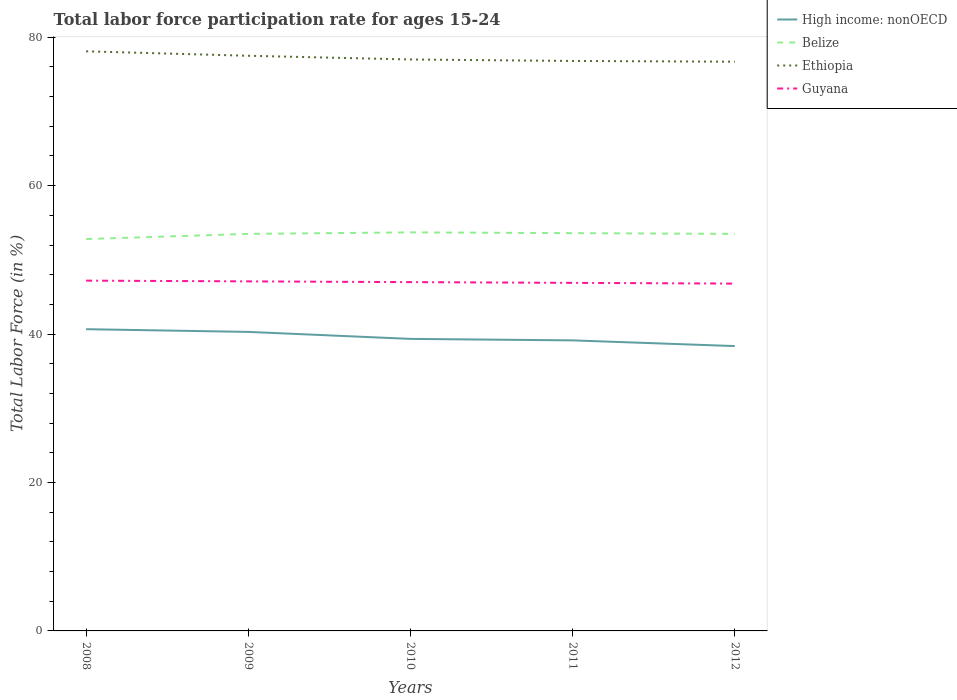Does the line corresponding to Belize intersect with the line corresponding to Ethiopia?
Your response must be concise. No. Is the number of lines equal to the number of legend labels?
Make the answer very short. Yes. Across all years, what is the maximum labor force participation rate in Belize?
Provide a short and direct response. 52.8. What is the total labor force participation rate in Ethiopia in the graph?
Your answer should be compact. 0.6. What is the difference between the highest and the second highest labor force participation rate in Ethiopia?
Ensure brevity in your answer.  1.4. What is the difference between the highest and the lowest labor force participation rate in Ethiopia?
Your response must be concise. 2. Is the labor force participation rate in Guyana strictly greater than the labor force participation rate in High income: nonOECD over the years?
Your answer should be compact. No. How many lines are there?
Your response must be concise. 4. What is the difference between two consecutive major ticks on the Y-axis?
Give a very brief answer. 20. Are the values on the major ticks of Y-axis written in scientific E-notation?
Offer a terse response. No. Does the graph contain grids?
Ensure brevity in your answer.  No. How many legend labels are there?
Keep it short and to the point. 4. What is the title of the graph?
Provide a short and direct response. Total labor force participation rate for ages 15-24. Does "Dominican Republic" appear as one of the legend labels in the graph?
Ensure brevity in your answer.  No. What is the Total Labor Force (in %) in High income: nonOECD in 2008?
Keep it short and to the point. 40.66. What is the Total Labor Force (in %) in Belize in 2008?
Your response must be concise. 52.8. What is the Total Labor Force (in %) in Ethiopia in 2008?
Your answer should be compact. 78.1. What is the Total Labor Force (in %) in Guyana in 2008?
Make the answer very short. 47.2. What is the Total Labor Force (in %) in High income: nonOECD in 2009?
Keep it short and to the point. 40.29. What is the Total Labor Force (in %) of Belize in 2009?
Give a very brief answer. 53.5. What is the Total Labor Force (in %) of Ethiopia in 2009?
Your answer should be very brief. 77.5. What is the Total Labor Force (in %) in Guyana in 2009?
Ensure brevity in your answer.  47.1. What is the Total Labor Force (in %) of High income: nonOECD in 2010?
Your answer should be compact. 39.35. What is the Total Labor Force (in %) in Belize in 2010?
Your answer should be compact. 53.7. What is the Total Labor Force (in %) in Ethiopia in 2010?
Keep it short and to the point. 77. What is the Total Labor Force (in %) of Guyana in 2010?
Keep it short and to the point. 47. What is the Total Labor Force (in %) in High income: nonOECD in 2011?
Your answer should be very brief. 39.15. What is the Total Labor Force (in %) of Belize in 2011?
Ensure brevity in your answer.  53.6. What is the Total Labor Force (in %) of Ethiopia in 2011?
Offer a very short reply. 76.8. What is the Total Labor Force (in %) of Guyana in 2011?
Your answer should be compact. 46.9. What is the Total Labor Force (in %) in High income: nonOECD in 2012?
Keep it short and to the point. 38.38. What is the Total Labor Force (in %) in Belize in 2012?
Your answer should be very brief. 53.5. What is the Total Labor Force (in %) of Ethiopia in 2012?
Provide a succinct answer. 76.7. What is the Total Labor Force (in %) of Guyana in 2012?
Provide a short and direct response. 46.8. Across all years, what is the maximum Total Labor Force (in %) of High income: nonOECD?
Offer a very short reply. 40.66. Across all years, what is the maximum Total Labor Force (in %) of Belize?
Offer a very short reply. 53.7. Across all years, what is the maximum Total Labor Force (in %) in Ethiopia?
Provide a succinct answer. 78.1. Across all years, what is the maximum Total Labor Force (in %) of Guyana?
Your answer should be very brief. 47.2. Across all years, what is the minimum Total Labor Force (in %) in High income: nonOECD?
Your answer should be compact. 38.38. Across all years, what is the minimum Total Labor Force (in %) in Belize?
Your answer should be compact. 52.8. Across all years, what is the minimum Total Labor Force (in %) of Ethiopia?
Give a very brief answer. 76.7. Across all years, what is the minimum Total Labor Force (in %) in Guyana?
Keep it short and to the point. 46.8. What is the total Total Labor Force (in %) of High income: nonOECD in the graph?
Offer a very short reply. 197.83. What is the total Total Labor Force (in %) of Belize in the graph?
Keep it short and to the point. 267.1. What is the total Total Labor Force (in %) in Ethiopia in the graph?
Give a very brief answer. 386.1. What is the total Total Labor Force (in %) in Guyana in the graph?
Your response must be concise. 235. What is the difference between the Total Labor Force (in %) of High income: nonOECD in 2008 and that in 2009?
Make the answer very short. 0.37. What is the difference between the Total Labor Force (in %) in Belize in 2008 and that in 2009?
Make the answer very short. -0.7. What is the difference between the Total Labor Force (in %) in High income: nonOECD in 2008 and that in 2010?
Provide a short and direct response. 1.31. What is the difference between the Total Labor Force (in %) of Belize in 2008 and that in 2010?
Make the answer very short. -0.9. What is the difference between the Total Labor Force (in %) of High income: nonOECD in 2008 and that in 2011?
Your answer should be very brief. 1.51. What is the difference between the Total Labor Force (in %) of Belize in 2008 and that in 2011?
Provide a succinct answer. -0.8. What is the difference between the Total Labor Force (in %) of High income: nonOECD in 2008 and that in 2012?
Provide a short and direct response. 2.28. What is the difference between the Total Labor Force (in %) of Belize in 2008 and that in 2012?
Make the answer very short. -0.7. What is the difference between the Total Labor Force (in %) in Guyana in 2008 and that in 2012?
Offer a terse response. 0.4. What is the difference between the Total Labor Force (in %) of High income: nonOECD in 2009 and that in 2010?
Provide a succinct answer. 0.94. What is the difference between the Total Labor Force (in %) of Belize in 2009 and that in 2010?
Keep it short and to the point. -0.2. What is the difference between the Total Labor Force (in %) of Ethiopia in 2009 and that in 2010?
Offer a terse response. 0.5. What is the difference between the Total Labor Force (in %) of Guyana in 2009 and that in 2010?
Your response must be concise. 0.1. What is the difference between the Total Labor Force (in %) of High income: nonOECD in 2009 and that in 2011?
Your response must be concise. 1.14. What is the difference between the Total Labor Force (in %) in Belize in 2009 and that in 2011?
Provide a short and direct response. -0.1. What is the difference between the Total Labor Force (in %) in Ethiopia in 2009 and that in 2011?
Keep it short and to the point. 0.7. What is the difference between the Total Labor Force (in %) of Guyana in 2009 and that in 2011?
Keep it short and to the point. 0.2. What is the difference between the Total Labor Force (in %) in High income: nonOECD in 2009 and that in 2012?
Offer a terse response. 1.91. What is the difference between the Total Labor Force (in %) of Belize in 2009 and that in 2012?
Provide a succinct answer. 0. What is the difference between the Total Labor Force (in %) of Ethiopia in 2009 and that in 2012?
Offer a very short reply. 0.8. What is the difference between the Total Labor Force (in %) in Guyana in 2009 and that in 2012?
Your answer should be compact. 0.3. What is the difference between the Total Labor Force (in %) in High income: nonOECD in 2010 and that in 2011?
Your response must be concise. 0.2. What is the difference between the Total Labor Force (in %) in Ethiopia in 2010 and that in 2011?
Your answer should be very brief. 0.2. What is the difference between the Total Labor Force (in %) of Guyana in 2010 and that in 2011?
Provide a succinct answer. 0.1. What is the difference between the Total Labor Force (in %) in High income: nonOECD in 2010 and that in 2012?
Your answer should be compact. 0.97. What is the difference between the Total Labor Force (in %) in Belize in 2010 and that in 2012?
Give a very brief answer. 0.2. What is the difference between the Total Labor Force (in %) in Ethiopia in 2010 and that in 2012?
Make the answer very short. 0.3. What is the difference between the Total Labor Force (in %) in Guyana in 2010 and that in 2012?
Provide a succinct answer. 0.2. What is the difference between the Total Labor Force (in %) in High income: nonOECD in 2011 and that in 2012?
Provide a succinct answer. 0.77. What is the difference between the Total Labor Force (in %) of Belize in 2011 and that in 2012?
Offer a terse response. 0.1. What is the difference between the Total Labor Force (in %) of High income: nonOECD in 2008 and the Total Labor Force (in %) of Belize in 2009?
Make the answer very short. -12.84. What is the difference between the Total Labor Force (in %) in High income: nonOECD in 2008 and the Total Labor Force (in %) in Ethiopia in 2009?
Give a very brief answer. -36.84. What is the difference between the Total Labor Force (in %) in High income: nonOECD in 2008 and the Total Labor Force (in %) in Guyana in 2009?
Provide a short and direct response. -6.44. What is the difference between the Total Labor Force (in %) in Belize in 2008 and the Total Labor Force (in %) in Ethiopia in 2009?
Your answer should be compact. -24.7. What is the difference between the Total Labor Force (in %) in Belize in 2008 and the Total Labor Force (in %) in Guyana in 2009?
Your response must be concise. 5.7. What is the difference between the Total Labor Force (in %) in High income: nonOECD in 2008 and the Total Labor Force (in %) in Belize in 2010?
Give a very brief answer. -13.04. What is the difference between the Total Labor Force (in %) of High income: nonOECD in 2008 and the Total Labor Force (in %) of Ethiopia in 2010?
Your answer should be compact. -36.34. What is the difference between the Total Labor Force (in %) in High income: nonOECD in 2008 and the Total Labor Force (in %) in Guyana in 2010?
Offer a terse response. -6.34. What is the difference between the Total Labor Force (in %) in Belize in 2008 and the Total Labor Force (in %) in Ethiopia in 2010?
Give a very brief answer. -24.2. What is the difference between the Total Labor Force (in %) in Ethiopia in 2008 and the Total Labor Force (in %) in Guyana in 2010?
Offer a very short reply. 31.1. What is the difference between the Total Labor Force (in %) in High income: nonOECD in 2008 and the Total Labor Force (in %) in Belize in 2011?
Offer a terse response. -12.94. What is the difference between the Total Labor Force (in %) of High income: nonOECD in 2008 and the Total Labor Force (in %) of Ethiopia in 2011?
Offer a very short reply. -36.14. What is the difference between the Total Labor Force (in %) of High income: nonOECD in 2008 and the Total Labor Force (in %) of Guyana in 2011?
Your answer should be very brief. -6.24. What is the difference between the Total Labor Force (in %) in Belize in 2008 and the Total Labor Force (in %) in Guyana in 2011?
Your response must be concise. 5.9. What is the difference between the Total Labor Force (in %) in Ethiopia in 2008 and the Total Labor Force (in %) in Guyana in 2011?
Offer a very short reply. 31.2. What is the difference between the Total Labor Force (in %) in High income: nonOECD in 2008 and the Total Labor Force (in %) in Belize in 2012?
Your answer should be very brief. -12.84. What is the difference between the Total Labor Force (in %) in High income: nonOECD in 2008 and the Total Labor Force (in %) in Ethiopia in 2012?
Provide a short and direct response. -36.04. What is the difference between the Total Labor Force (in %) of High income: nonOECD in 2008 and the Total Labor Force (in %) of Guyana in 2012?
Your response must be concise. -6.14. What is the difference between the Total Labor Force (in %) in Belize in 2008 and the Total Labor Force (in %) in Ethiopia in 2012?
Give a very brief answer. -23.9. What is the difference between the Total Labor Force (in %) in Ethiopia in 2008 and the Total Labor Force (in %) in Guyana in 2012?
Your answer should be compact. 31.3. What is the difference between the Total Labor Force (in %) of High income: nonOECD in 2009 and the Total Labor Force (in %) of Belize in 2010?
Offer a terse response. -13.41. What is the difference between the Total Labor Force (in %) in High income: nonOECD in 2009 and the Total Labor Force (in %) in Ethiopia in 2010?
Provide a succinct answer. -36.71. What is the difference between the Total Labor Force (in %) of High income: nonOECD in 2009 and the Total Labor Force (in %) of Guyana in 2010?
Give a very brief answer. -6.71. What is the difference between the Total Labor Force (in %) in Belize in 2009 and the Total Labor Force (in %) in Ethiopia in 2010?
Make the answer very short. -23.5. What is the difference between the Total Labor Force (in %) in Belize in 2009 and the Total Labor Force (in %) in Guyana in 2010?
Your answer should be compact. 6.5. What is the difference between the Total Labor Force (in %) of Ethiopia in 2009 and the Total Labor Force (in %) of Guyana in 2010?
Your answer should be very brief. 30.5. What is the difference between the Total Labor Force (in %) in High income: nonOECD in 2009 and the Total Labor Force (in %) in Belize in 2011?
Provide a short and direct response. -13.31. What is the difference between the Total Labor Force (in %) in High income: nonOECD in 2009 and the Total Labor Force (in %) in Ethiopia in 2011?
Your answer should be compact. -36.51. What is the difference between the Total Labor Force (in %) of High income: nonOECD in 2009 and the Total Labor Force (in %) of Guyana in 2011?
Your answer should be compact. -6.61. What is the difference between the Total Labor Force (in %) in Belize in 2009 and the Total Labor Force (in %) in Ethiopia in 2011?
Give a very brief answer. -23.3. What is the difference between the Total Labor Force (in %) of Belize in 2009 and the Total Labor Force (in %) of Guyana in 2011?
Provide a succinct answer. 6.6. What is the difference between the Total Labor Force (in %) in Ethiopia in 2009 and the Total Labor Force (in %) in Guyana in 2011?
Make the answer very short. 30.6. What is the difference between the Total Labor Force (in %) of High income: nonOECD in 2009 and the Total Labor Force (in %) of Belize in 2012?
Provide a succinct answer. -13.21. What is the difference between the Total Labor Force (in %) of High income: nonOECD in 2009 and the Total Labor Force (in %) of Ethiopia in 2012?
Offer a terse response. -36.41. What is the difference between the Total Labor Force (in %) of High income: nonOECD in 2009 and the Total Labor Force (in %) of Guyana in 2012?
Give a very brief answer. -6.51. What is the difference between the Total Labor Force (in %) in Belize in 2009 and the Total Labor Force (in %) in Ethiopia in 2012?
Offer a very short reply. -23.2. What is the difference between the Total Labor Force (in %) of Belize in 2009 and the Total Labor Force (in %) of Guyana in 2012?
Provide a short and direct response. 6.7. What is the difference between the Total Labor Force (in %) of Ethiopia in 2009 and the Total Labor Force (in %) of Guyana in 2012?
Provide a short and direct response. 30.7. What is the difference between the Total Labor Force (in %) in High income: nonOECD in 2010 and the Total Labor Force (in %) in Belize in 2011?
Offer a terse response. -14.25. What is the difference between the Total Labor Force (in %) of High income: nonOECD in 2010 and the Total Labor Force (in %) of Ethiopia in 2011?
Keep it short and to the point. -37.45. What is the difference between the Total Labor Force (in %) of High income: nonOECD in 2010 and the Total Labor Force (in %) of Guyana in 2011?
Keep it short and to the point. -7.55. What is the difference between the Total Labor Force (in %) of Belize in 2010 and the Total Labor Force (in %) of Ethiopia in 2011?
Your answer should be very brief. -23.1. What is the difference between the Total Labor Force (in %) in Ethiopia in 2010 and the Total Labor Force (in %) in Guyana in 2011?
Make the answer very short. 30.1. What is the difference between the Total Labor Force (in %) in High income: nonOECD in 2010 and the Total Labor Force (in %) in Belize in 2012?
Make the answer very short. -14.15. What is the difference between the Total Labor Force (in %) of High income: nonOECD in 2010 and the Total Labor Force (in %) of Ethiopia in 2012?
Keep it short and to the point. -37.35. What is the difference between the Total Labor Force (in %) of High income: nonOECD in 2010 and the Total Labor Force (in %) of Guyana in 2012?
Provide a short and direct response. -7.45. What is the difference between the Total Labor Force (in %) of Ethiopia in 2010 and the Total Labor Force (in %) of Guyana in 2012?
Offer a very short reply. 30.2. What is the difference between the Total Labor Force (in %) of High income: nonOECD in 2011 and the Total Labor Force (in %) of Belize in 2012?
Keep it short and to the point. -14.35. What is the difference between the Total Labor Force (in %) of High income: nonOECD in 2011 and the Total Labor Force (in %) of Ethiopia in 2012?
Give a very brief answer. -37.55. What is the difference between the Total Labor Force (in %) of High income: nonOECD in 2011 and the Total Labor Force (in %) of Guyana in 2012?
Make the answer very short. -7.65. What is the difference between the Total Labor Force (in %) in Belize in 2011 and the Total Labor Force (in %) in Ethiopia in 2012?
Offer a very short reply. -23.1. What is the difference between the Total Labor Force (in %) of Belize in 2011 and the Total Labor Force (in %) of Guyana in 2012?
Ensure brevity in your answer.  6.8. What is the difference between the Total Labor Force (in %) in Ethiopia in 2011 and the Total Labor Force (in %) in Guyana in 2012?
Your answer should be compact. 30. What is the average Total Labor Force (in %) in High income: nonOECD per year?
Keep it short and to the point. 39.57. What is the average Total Labor Force (in %) in Belize per year?
Make the answer very short. 53.42. What is the average Total Labor Force (in %) of Ethiopia per year?
Make the answer very short. 77.22. What is the average Total Labor Force (in %) in Guyana per year?
Offer a terse response. 47. In the year 2008, what is the difference between the Total Labor Force (in %) in High income: nonOECD and Total Labor Force (in %) in Belize?
Ensure brevity in your answer.  -12.14. In the year 2008, what is the difference between the Total Labor Force (in %) in High income: nonOECD and Total Labor Force (in %) in Ethiopia?
Your answer should be very brief. -37.44. In the year 2008, what is the difference between the Total Labor Force (in %) of High income: nonOECD and Total Labor Force (in %) of Guyana?
Your answer should be very brief. -6.54. In the year 2008, what is the difference between the Total Labor Force (in %) in Belize and Total Labor Force (in %) in Ethiopia?
Your answer should be compact. -25.3. In the year 2008, what is the difference between the Total Labor Force (in %) of Ethiopia and Total Labor Force (in %) of Guyana?
Offer a terse response. 30.9. In the year 2009, what is the difference between the Total Labor Force (in %) of High income: nonOECD and Total Labor Force (in %) of Belize?
Offer a terse response. -13.21. In the year 2009, what is the difference between the Total Labor Force (in %) in High income: nonOECD and Total Labor Force (in %) in Ethiopia?
Provide a succinct answer. -37.21. In the year 2009, what is the difference between the Total Labor Force (in %) in High income: nonOECD and Total Labor Force (in %) in Guyana?
Your answer should be compact. -6.81. In the year 2009, what is the difference between the Total Labor Force (in %) in Belize and Total Labor Force (in %) in Ethiopia?
Your response must be concise. -24. In the year 2009, what is the difference between the Total Labor Force (in %) of Ethiopia and Total Labor Force (in %) of Guyana?
Your answer should be very brief. 30.4. In the year 2010, what is the difference between the Total Labor Force (in %) of High income: nonOECD and Total Labor Force (in %) of Belize?
Offer a very short reply. -14.35. In the year 2010, what is the difference between the Total Labor Force (in %) of High income: nonOECD and Total Labor Force (in %) of Ethiopia?
Your answer should be compact. -37.65. In the year 2010, what is the difference between the Total Labor Force (in %) in High income: nonOECD and Total Labor Force (in %) in Guyana?
Your response must be concise. -7.65. In the year 2010, what is the difference between the Total Labor Force (in %) in Belize and Total Labor Force (in %) in Ethiopia?
Ensure brevity in your answer.  -23.3. In the year 2011, what is the difference between the Total Labor Force (in %) in High income: nonOECD and Total Labor Force (in %) in Belize?
Make the answer very short. -14.45. In the year 2011, what is the difference between the Total Labor Force (in %) in High income: nonOECD and Total Labor Force (in %) in Ethiopia?
Provide a succinct answer. -37.65. In the year 2011, what is the difference between the Total Labor Force (in %) of High income: nonOECD and Total Labor Force (in %) of Guyana?
Make the answer very short. -7.75. In the year 2011, what is the difference between the Total Labor Force (in %) in Belize and Total Labor Force (in %) in Ethiopia?
Provide a succinct answer. -23.2. In the year 2011, what is the difference between the Total Labor Force (in %) of Belize and Total Labor Force (in %) of Guyana?
Offer a very short reply. 6.7. In the year 2011, what is the difference between the Total Labor Force (in %) of Ethiopia and Total Labor Force (in %) of Guyana?
Make the answer very short. 29.9. In the year 2012, what is the difference between the Total Labor Force (in %) of High income: nonOECD and Total Labor Force (in %) of Belize?
Keep it short and to the point. -15.12. In the year 2012, what is the difference between the Total Labor Force (in %) of High income: nonOECD and Total Labor Force (in %) of Ethiopia?
Keep it short and to the point. -38.32. In the year 2012, what is the difference between the Total Labor Force (in %) in High income: nonOECD and Total Labor Force (in %) in Guyana?
Keep it short and to the point. -8.42. In the year 2012, what is the difference between the Total Labor Force (in %) in Belize and Total Labor Force (in %) in Ethiopia?
Provide a short and direct response. -23.2. In the year 2012, what is the difference between the Total Labor Force (in %) in Belize and Total Labor Force (in %) in Guyana?
Make the answer very short. 6.7. In the year 2012, what is the difference between the Total Labor Force (in %) in Ethiopia and Total Labor Force (in %) in Guyana?
Keep it short and to the point. 29.9. What is the ratio of the Total Labor Force (in %) in High income: nonOECD in 2008 to that in 2009?
Offer a terse response. 1.01. What is the ratio of the Total Labor Force (in %) of Belize in 2008 to that in 2009?
Keep it short and to the point. 0.99. What is the ratio of the Total Labor Force (in %) of Ethiopia in 2008 to that in 2009?
Provide a short and direct response. 1.01. What is the ratio of the Total Labor Force (in %) of High income: nonOECD in 2008 to that in 2010?
Ensure brevity in your answer.  1.03. What is the ratio of the Total Labor Force (in %) of Belize in 2008 to that in 2010?
Ensure brevity in your answer.  0.98. What is the ratio of the Total Labor Force (in %) in Ethiopia in 2008 to that in 2010?
Provide a short and direct response. 1.01. What is the ratio of the Total Labor Force (in %) of Belize in 2008 to that in 2011?
Offer a very short reply. 0.99. What is the ratio of the Total Labor Force (in %) of Ethiopia in 2008 to that in 2011?
Provide a short and direct response. 1.02. What is the ratio of the Total Labor Force (in %) of Guyana in 2008 to that in 2011?
Make the answer very short. 1.01. What is the ratio of the Total Labor Force (in %) of High income: nonOECD in 2008 to that in 2012?
Your answer should be compact. 1.06. What is the ratio of the Total Labor Force (in %) of Belize in 2008 to that in 2012?
Your answer should be very brief. 0.99. What is the ratio of the Total Labor Force (in %) in Ethiopia in 2008 to that in 2012?
Your response must be concise. 1.02. What is the ratio of the Total Labor Force (in %) in Guyana in 2008 to that in 2012?
Offer a very short reply. 1.01. What is the ratio of the Total Labor Force (in %) in High income: nonOECD in 2009 to that in 2010?
Keep it short and to the point. 1.02. What is the ratio of the Total Labor Force (in %) in Belize in 2009 to that in 2010?
Offer a very short reply. 1. What is the ratio of the Total Labor Force (in %) in High income: nonOECD in 2009 to that in 2011?
Offer a very short reply. 1.03. What is the ratio of the Total Labor Force (in %) in Belize in 2009 to that in 2011?
Ensure brevity in your answer.  1. What is the ratio of the Total Labor Force (in %) in Ethiopia in 2009 to that in 2011?
Offer a very short reply. 1.01. What is the ratio of the Total Labor Force (in %) in Guyana in 2009 to that in 2011?
Offer a terse response. 1. What is the ratio of the Total Labor Force (in %) of High income: nonOECD in 2009 to that in 2012?
Ensure brevity in your answer.  1.05. What is the ratio of the Total Labor Force (in %) of Belize in 2009 to that in 2012?
Provide a short and direct response. 1. What is the ratio of the Total Labor Force (in %) in Ethiopia in 2009 to that in 2012?
Provide a succinct answer. 1.01. What is the ratio of the Total Labor Force (in %) of Guyana in 2009 to that in 2012?
Offer a very short reply. 1.01. What is the ratio of the Total Labor Force (in %) in Ethiopia in 2010 to that in 2011?
Provide a short and direct response. 1. What is the ratio of the Total Labor Force (in %) in High income: nonOECD in 2010 to that in 2012?
Ensure brevity in your answer.  1.03. What is the ratio of the Total Labor Force (in %) of Belize in 2010 to that in 2012?
Your response must be concise. 1. What is the ratio of the Total Labor Force (in %) in Guyana in 2010 to that in 2012?
Your answer should be compact. 1. What is the ratio of the Total Labor Force (in %) in High income: nonOECD in 2011 to that in 2012?
Give a very brief answer. 1.02. What is the difference between the highest and the second highest Total Labor Force (in %) in High income: nonOECD?
Your response must be concise. 0.37. What is the difference between the highest and the second highest Total Labor Force (in %) of Ethiopia?
Your response must be concise. 0.6. What is the difference between the highest and the lowest Total Labor Force (in %) of High income: nonOECD?
Provide a succinct answer. 2.28. What is the difference between the highest and the lowest Total Labor Force (in %) in Guyana?
Give a very brief answer. 0.4. 